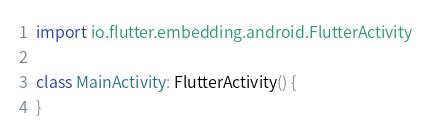Convert code to text. <code><loc_0><loc_0><loc_500><loc_500><_Kotlin_>import io.flutter.embedding.android.FlutterActivity

class MainActivity: FlutterActivity() {
}
</code> 